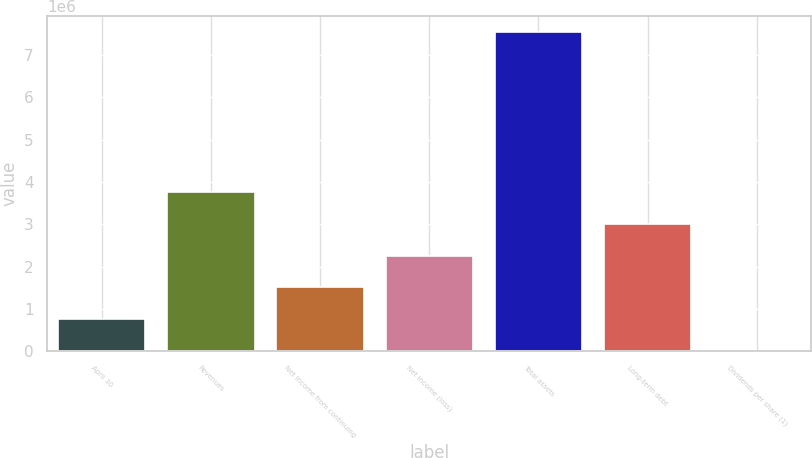Convert chart. <chart><loc_0><loc_0><loc_500><loc_500><bar_chart><fcel>April 30<fcel>Revenues<fcel>Net income from continuing<fcel>Net income (loss)<fcel>Total assets<fcel>Long-term debt<fcel>Dividends per share (1)<nl><fcel>754405<fcel>3.77203e+06<fcel>1.50881e+06<fcel>2.26322e+06<fcel>7.54405e+06<fcel>3.01762e+06<fcel>0.53<nl></chart> 